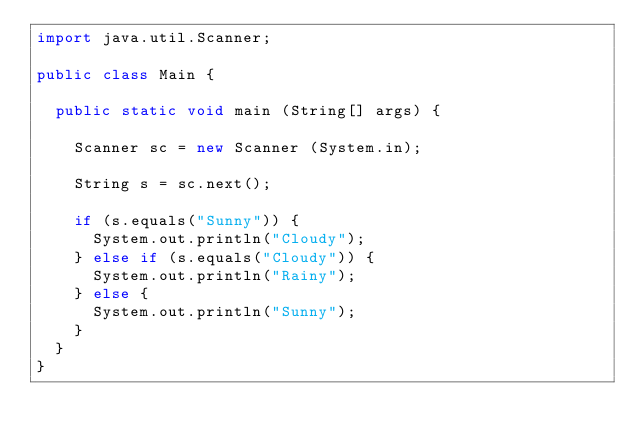<code> <loc_0><loc_0><loc_500><loc_500><_Java_>import java.util.Scanner;

public class Main {

	public static void main (String[] args) {

		Scanner sc = new Scanner (System.in);

		String s = sc.next();
		
		if (s.equals("Sunny")) {
			System.out.println("Cloudy");
		} else if (s.equals("Cloudy")) {
			System.out.println("Rainy");
		} else {
			System.out.println("Sunny");
		}
	}
}</code> 